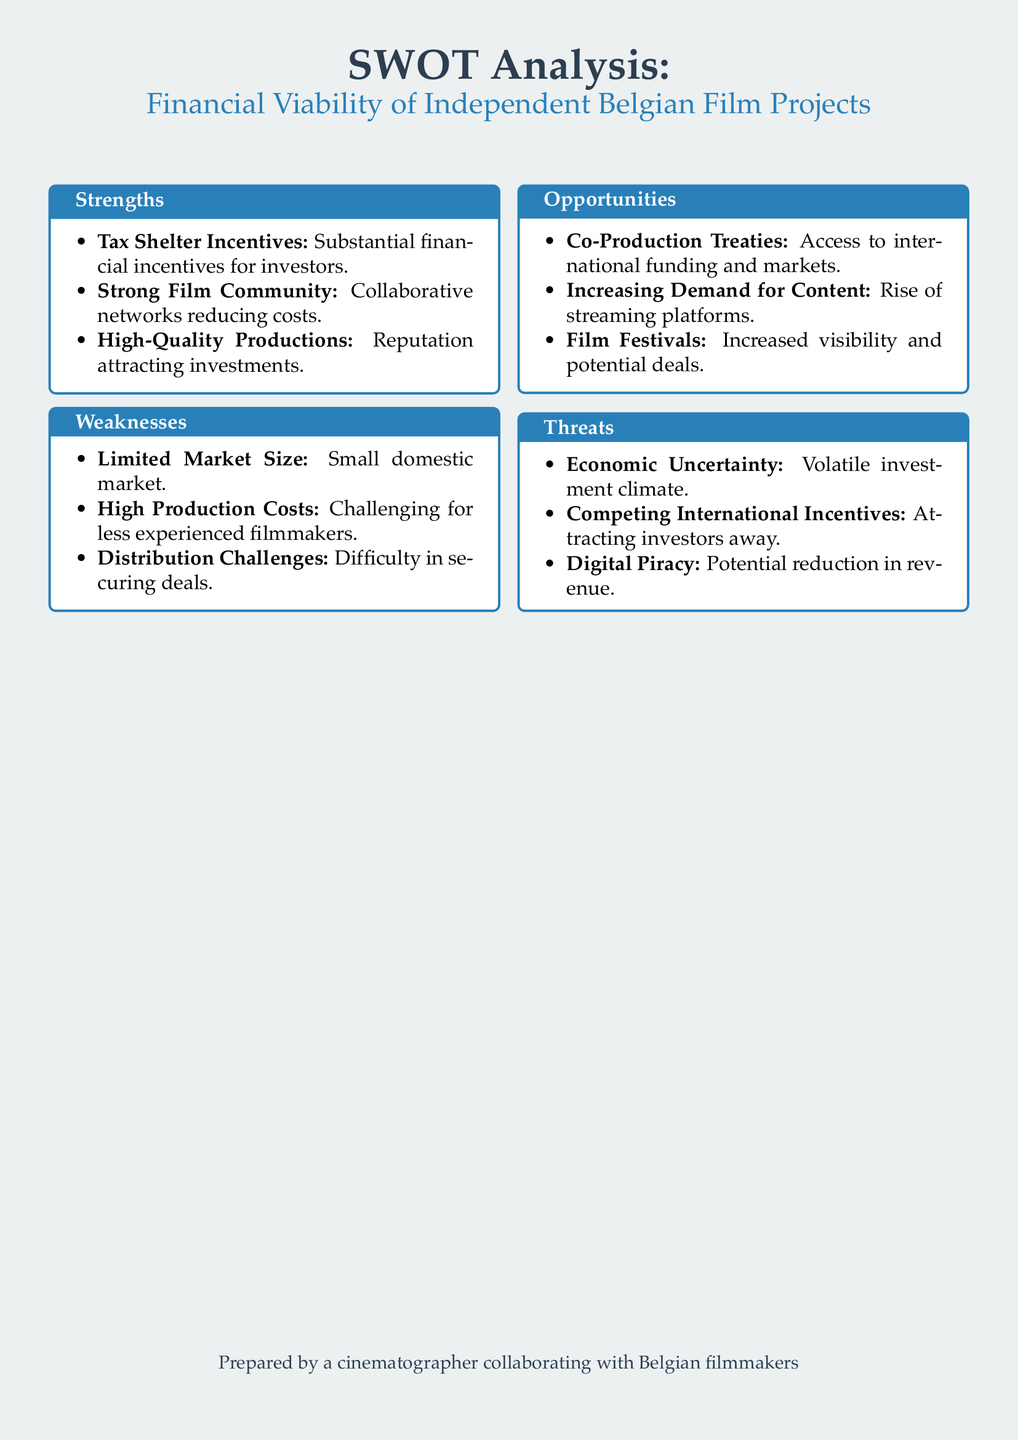what is one strength mentioned? The document lists strengths such as Tax Shelter Incentives, Strong Film Community, and High-Quality Productions.
Answer: Tax Shelter Incentives what is a weakness associated with independent Belgian films? The weaknesses include Limited Market Size, High Production Costs, and Distribution Challenges.
Answer: Limited Market Size name one opportunity for independent Belgian film projects. The opportunities highlighted are Co-Production Treaties, Increasing Demand for Content, and Film Festivals.
Answer: Co-Production Treaties what is a threat to independent Belgian film projects? The threats mentioned include Economic Uncertainty, Competing International Incentives, and Digital Piracy.
Answer: Economic Uncertainty how many strengths are listed in the document? The document has three strengths listed under the strengths section.
Answer: 3 which aspect of the film industry is highlighted as a reason for increased visibility? The document mentions Film Festivals as a way to gain increased visibility.
Answer: Film Festivals what does the SWOT analysis primarily assess? The central focus of the SWOT analysis is on the financial viability of independent Belgian film projects.
Answer: financial viability what is stated as a benefit of the strong film community? The document indicates that a strong film community helps in reducing costs.
Answer: reducing costs what external factor may impact the investment climate? The document mentions Economic Uncertainty as a potential factor affecting the investment climate.
Answer: Economic Uncertainty 